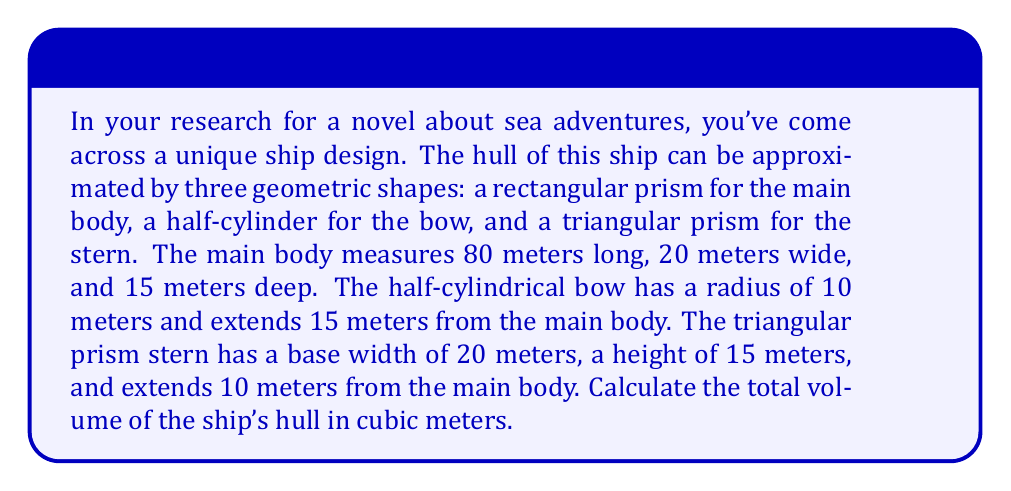Show me your answer to this math problem. To solve this problem, we need to calculate the volume of each component and then sum them up:

1. Main body (rectangular prism):
   $$V_{main} = l \times w \times h = 80 \times 20 \times 15 = 24,000 \text{ m}^3$$

2. Bow (half-cylinder):
   The volume of a full cylinder is $\pi r^2 h$, so for a half-cylinder:
   $$V_{bow} = \frac{1}{2} \pi r^2 h = \frac{1}{2} \pi \times 10^2 \times 15 = 2,356.19 \text{ m}^3$$

3. Stern (triangular prism):
   The volume of a triangular prism is the area of the triangular base times the length:
   $$V_{stern} = \frac{1}{2} \times \text{base} \times \text{height} \times \text{length} = \frac{1}{2} \times 20 \times 15 \times 10 = 1,500 \text{ m}^3$$

Total volume:
$$V_{total} = V_{main} + V_{bow} + V_{stern}$$
$$V_{total} = 24,000 + 2,356.19 + 1,500 = 27,856.19 \text{ m}^3$$

[asy]
import three;

size(200);
currentprojection=perspective(6,3,2);

// Main body
draw(box((0,0,0),(80,20,15)), blue);

// Bow (half-cylinder)
path3 semicircle = arc((80,0,0), (80,10,0), (80,0,15));
draw(semicircle -- (80,0,15) -- (80,0,0) -- cycle, blue);
draw(surface(semicircle -- (80,0,15) -- (80,0,0) -- cycle), blue+opacity(0.1));
draw(path3((95,0,0)--(95,20,0)--(95,20,15)--(95,0,15)--cycle), blue);

// Stern (triangular prism)
draw((0,0,0)--(0,20,0)--(0,10,15)--cycle, blue);
draw((10,0,0)--(10,20,0)--(10,10,15)--cycle, blue);
draw((0,0,0)--(10,0,0), blue);
draw((0,20,0)--(10,20,0), blue);
draw((0,10,15)--(10,10,15), blue);

[/asy]
Answer: The total volume of the ship's hull is approximately 27,856.19 cubic meters. 